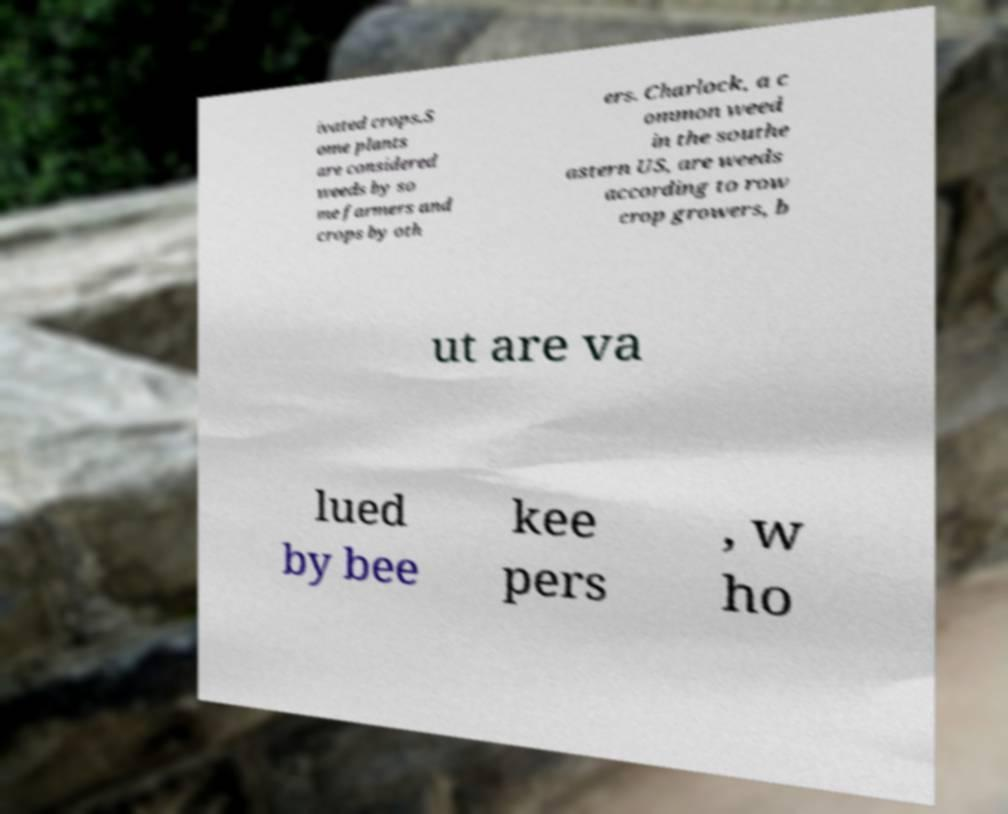Please read and relay the text visible in this image. What does it say? ivated crops.S ome plants are considered weeds by so me farmers and crops by oth ers. Charlock, a c ommon weed in the southe astern US, are weeds according to row crop growers, b ut are va lued by bee kee pers , w ho 